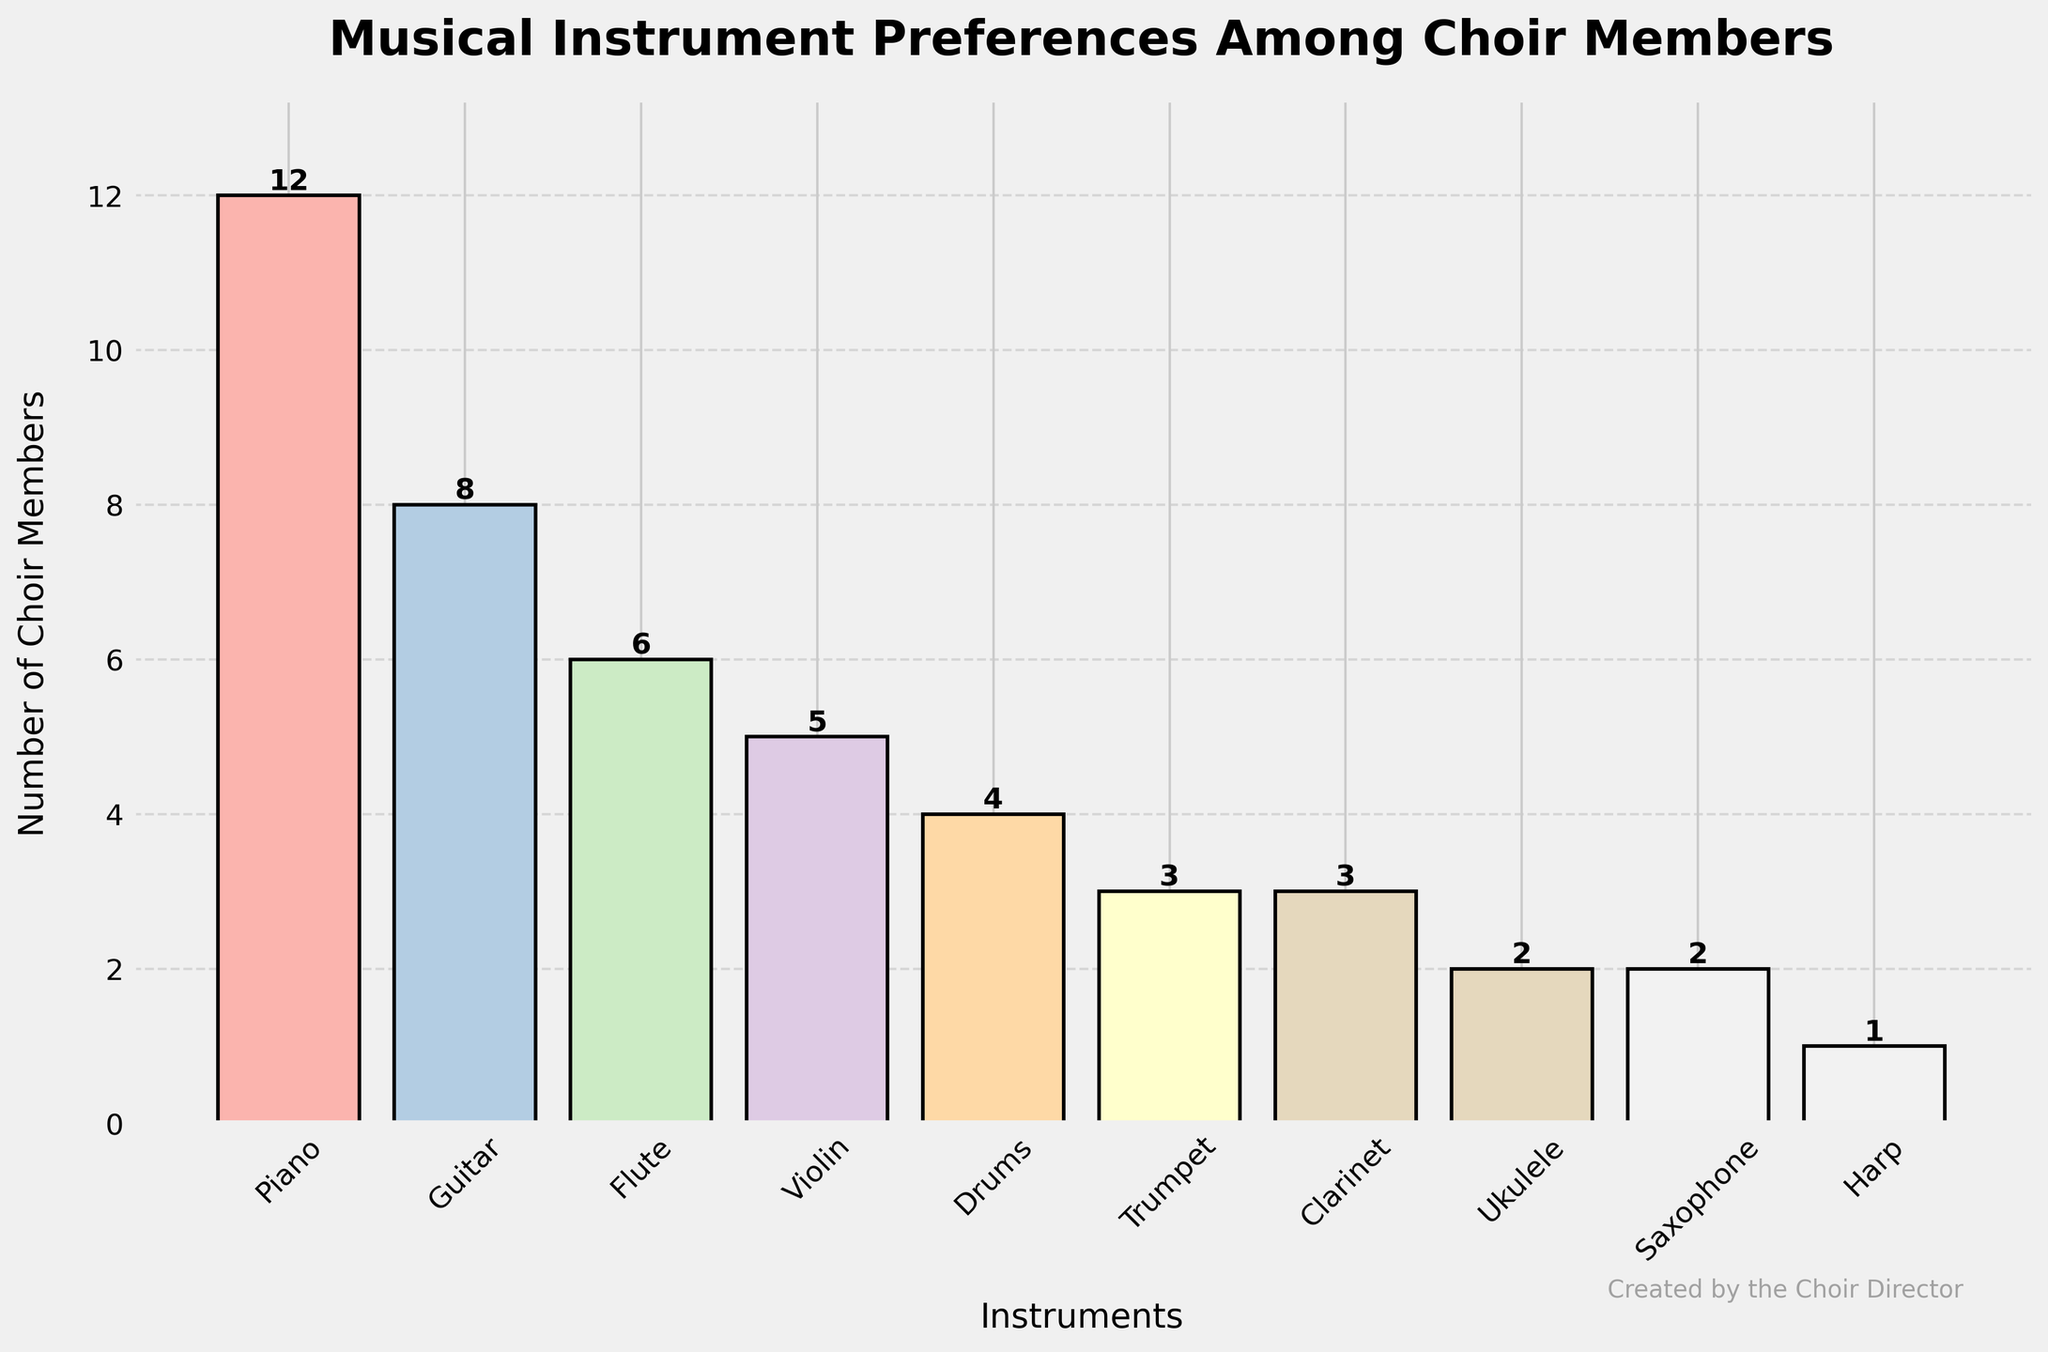Which instrument is preferred by the most choir members? By looking at the heights of the bars, the highest bar represents the Piano with 12 choir members.
Answer: Piano How many more choir members prefer the Piano over the Guitar? The bar for Piano shows 12 members, and the bar for Guitar shows 8 members. Subtracting these values, 12 - 8 = 4.
Answer: 4 Which instrument has the least number of choir members? The shortest bar corresponds to the Harp, which shows 1 choir member.
Answer: Harp What is the total number of choir members who prefer the Flute, Violin, and Clarinet combined? The bars show 6 members for Flute, 5 for Violin, and 3 for Clarinet. Adding these values, 6 + 5 + 3 = 14.
Answer: 14 How many members prefer string instruments (Piano, Guitar, Violin, Ukulele, Harp)? The bars represent 12 for Piano, 8 for Guitar, 5 for Violin, 2 for Ukulele, and 1 for Harp. Adding these values, 12 + 8 + 5 + 2 + 1 = 28.
Answer: 28 Is the number of members who prefer wind instruments (Flute, Trumpet, Clarinet, Saxophone) greater or lesser than those who prefer percussion instruments (Drums)? Adding members of wind instruments: 6 (Flute) + 3 (Trumpet) + 3 (Clarinet) + 2 (Saxophone) = 14. Comparing this to 4 members for Drums, 14 is greater than 4.
Answer: Greater What is the average number of choir members across all instruments? Summing the number of choir members for all instruments: 12 + 8 + 6 + 5 + 4 + 3 + 3 + 2 + 2 + 1 = 46. Dividing by the number of instruments (10), 46 / 10 = 4.6.
Answer: 4.6 How many more members prefer the Piano compared to those who prefer the Trumpet, Clarinet, and Saxophone combined? The number of Piano members is 12. Summing members for Trumpet, Clarinet, and Saxophone: 3 + 3 + 2 = 8. Subtracting these values, 12 - 8 = 4.
Answer: 4 Which instruments have an equal number of choir members? The bars for Trumpet and Clarinet both show 3 members each, and Ukulele and Saxophone both show 2 members each.
Answer: Trumpet and Clarinet, Ukulele and Saxophone 